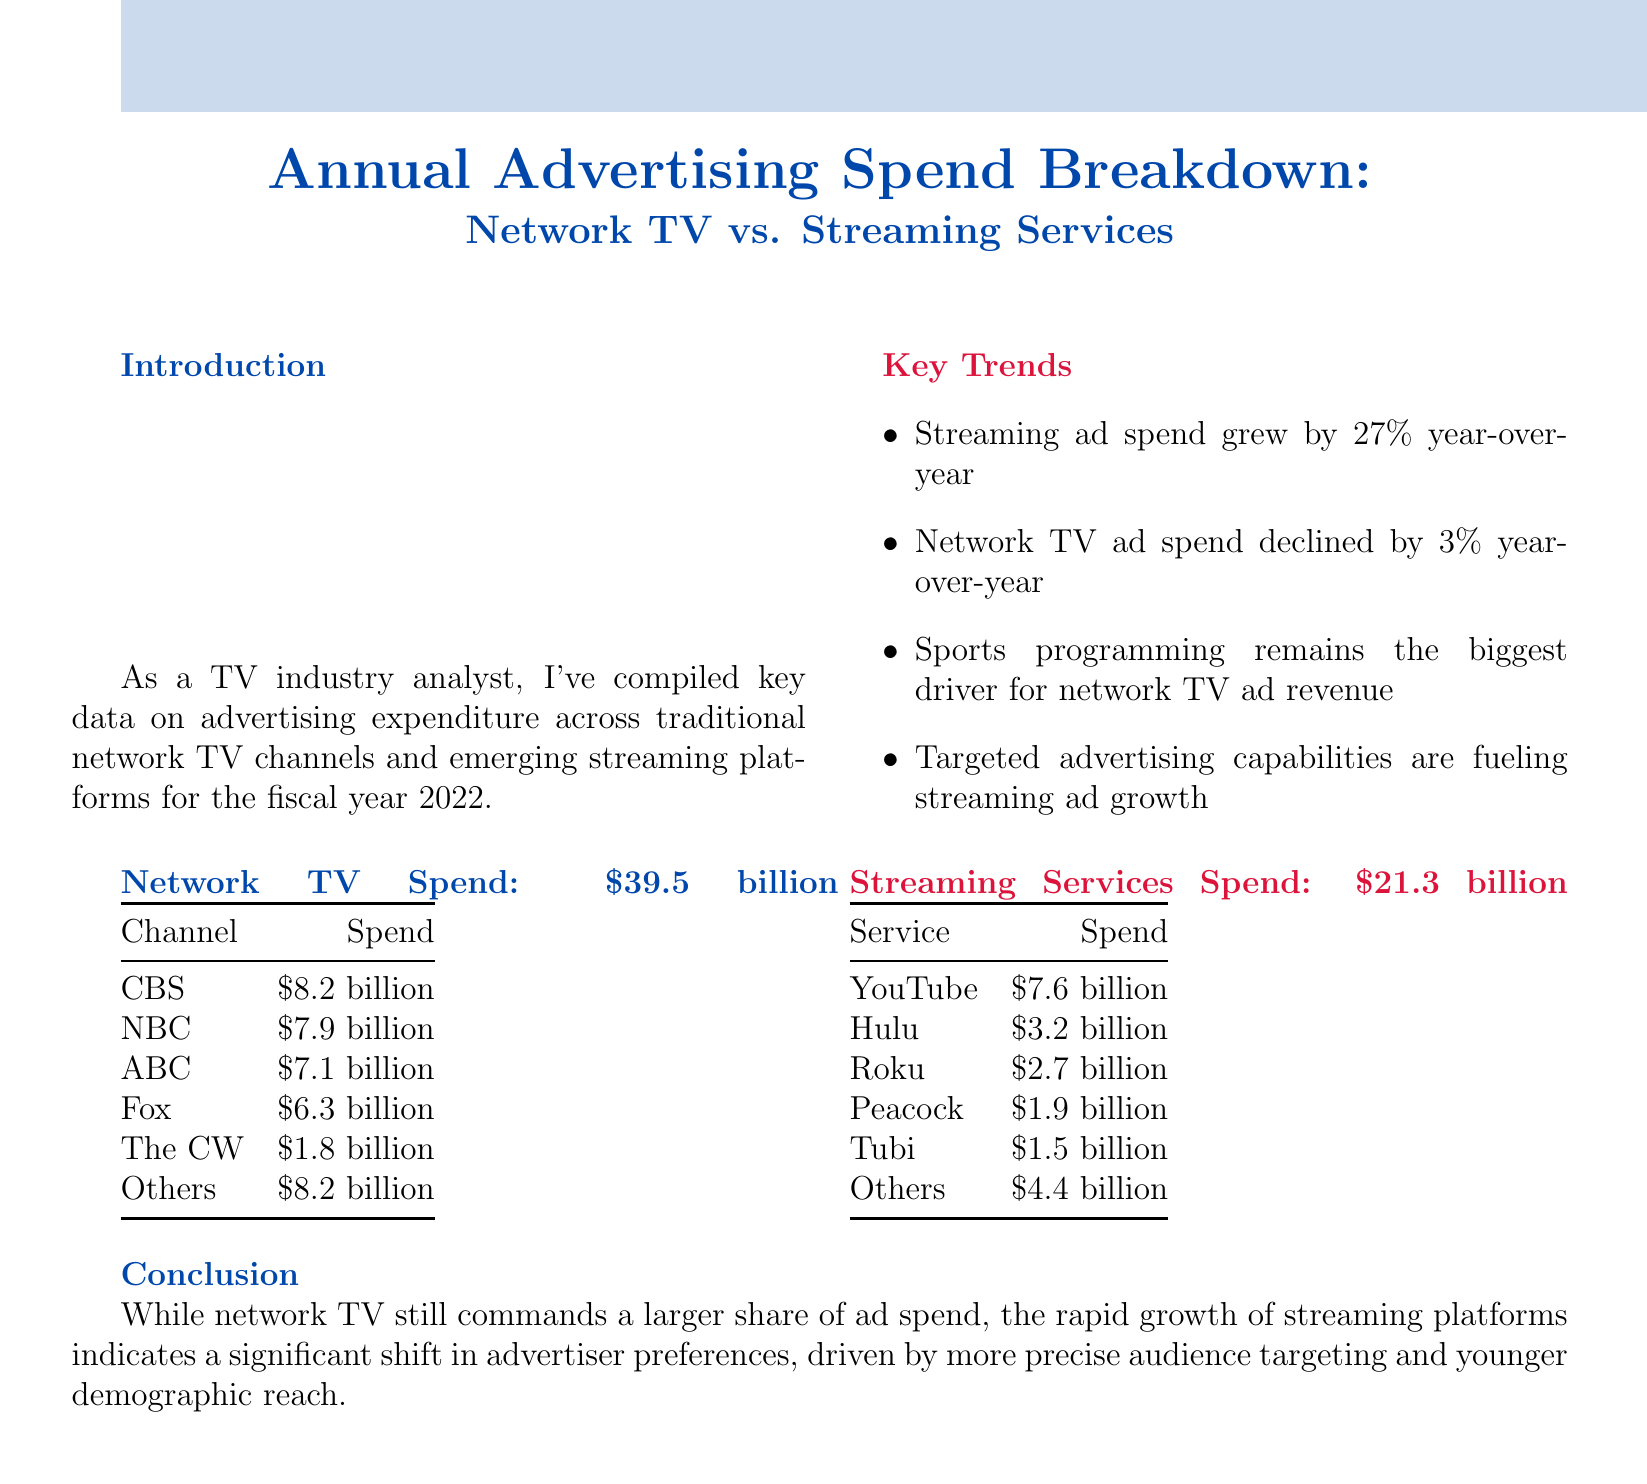What is the total advertising spend on network TV? The total advertising spend on network TV is listed in the breakdown section of the document.
Answer: $39.5 billion Who spent the most on advertising among network TV channels? The document provides a breakdown of spending across different channels, highlighting CBS as the highest spender.
Answer: CBS What is the total advertising spend on streaming services? The document specifies the total spend on streaming services directly.
Answer: $21.3 billion By what percentage did streaming ad spend grow year-over-year? The key trends section outlines the growth percentage for streaming ad spend compared to the previous year.
Answer: 27% Which platform accounted for the largest share of streaming ad spend? The breakdown indicates that YouTube had the highest advertising spend among streaming services.
Answer: YouTube How much did NBC spend on advertising? The breakdown provides specific spending amounts for each network channel, including NBC.
Answer: $7.9 billion What was the year-over-year change in network TV ad spend? The document includes information about the change in spending for network TV over the past year in the key trends.
Answer: Declined by 3% What demographic reach is influencing the growth of streaming ad spending? The conclusion mentions a specific demographic factor influencing streaming ad spend growth.
Answer: Younger demographic reach What is the advertising spend of the service named Tubi? The breakdown includes Tubi's specific advertising spend among streaming services.
Answer: $1.5 billion 